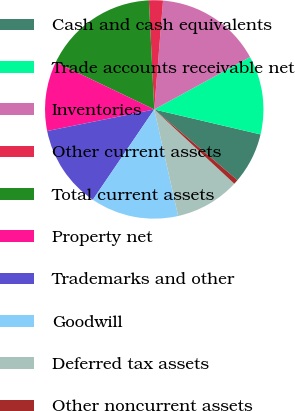Convert chart. <chart><loc_0><loc_0><loc_500><loc_500><pie_chart><fcel>Cash and cash equivalents<fcel>Trade accounts receivable net<fcel>Inventories<fcel>Other current assets<fcel>Total current assets<fcel>Property net<fcel>Trademarks and other<fcel>Goodwill<fcel>Deferred tax assets<fcel>Other noncurrent assets<nl><fcel>7.54%<fcel>11.64%<fcel>15.75%<fcel>2.06%<fcel>17.12%<fcel>10.27%<fcel>12.33%<fcel>13.01%<fcel>9.59%<fcel>0.69%<nl></chart> 